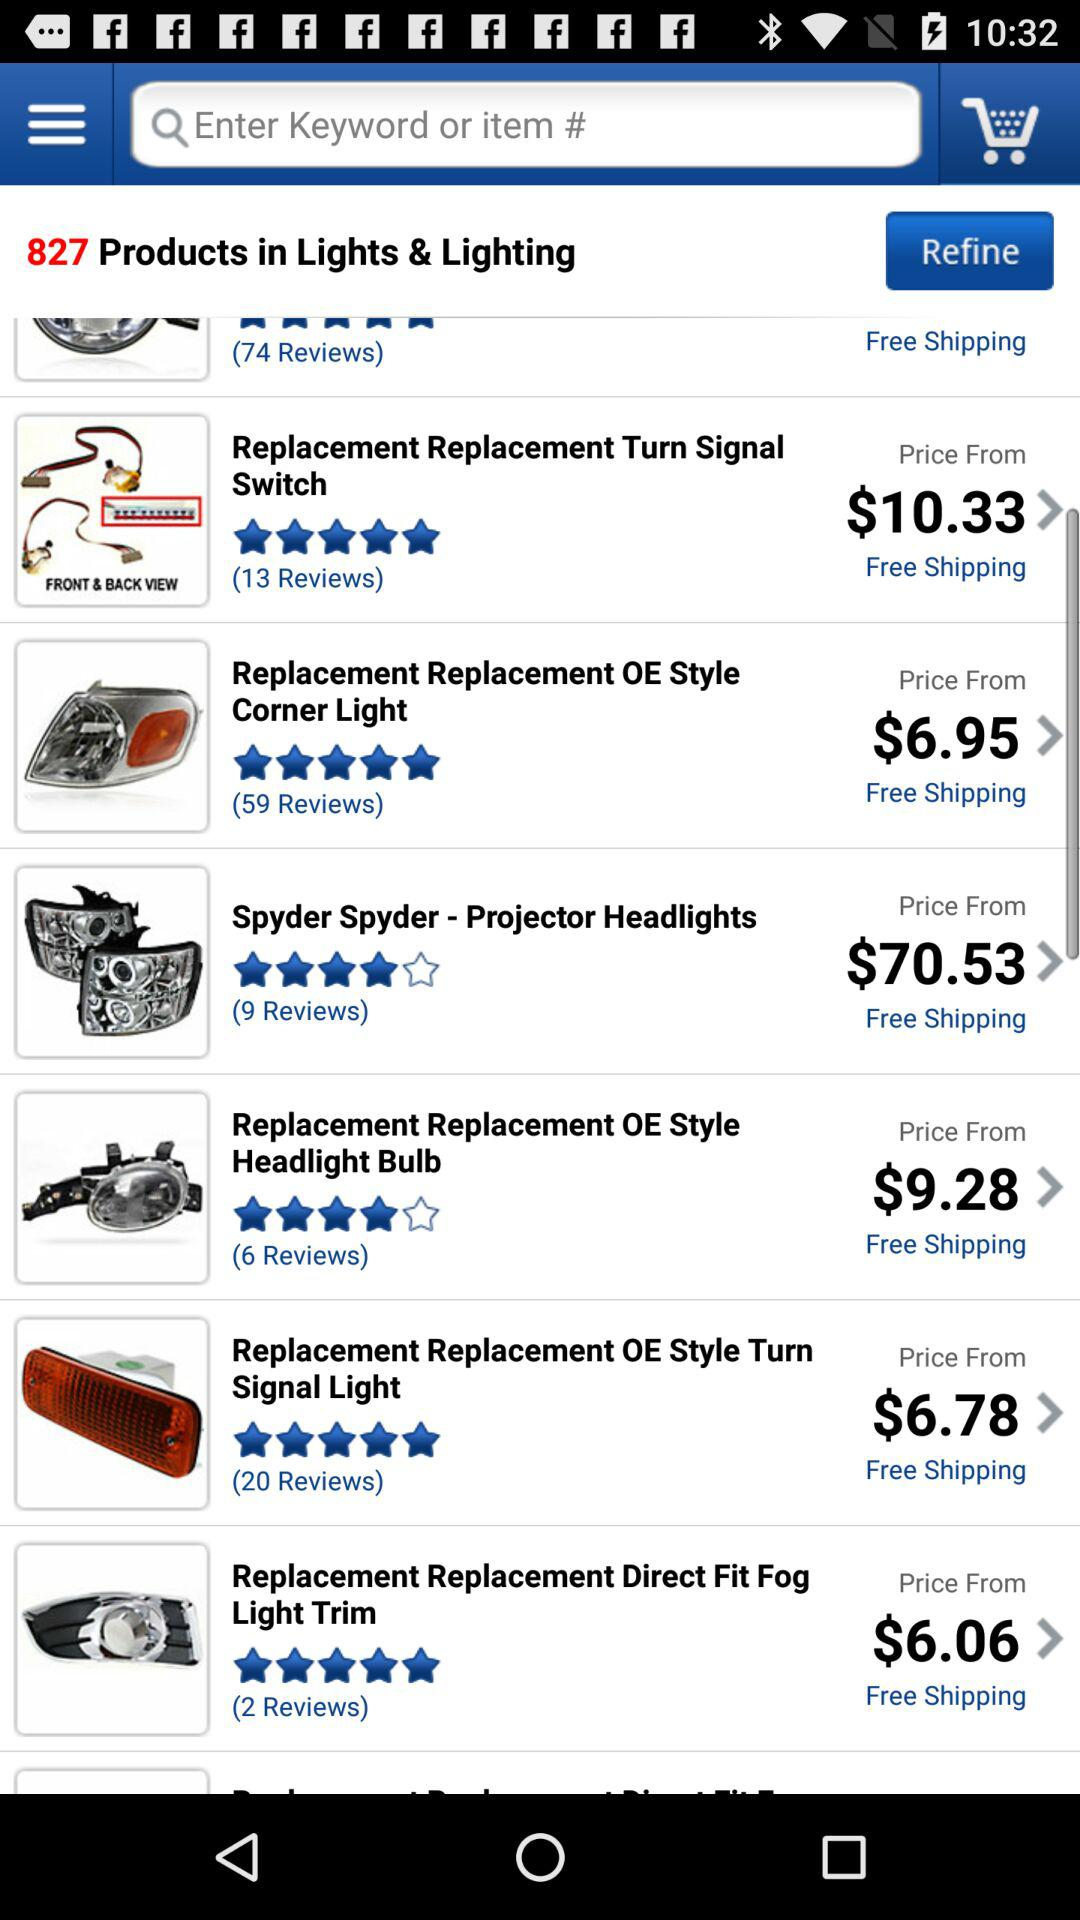How many products in total are in "Lights & Lighting"? In "Lights & Lighting", there are 827 products in total. 